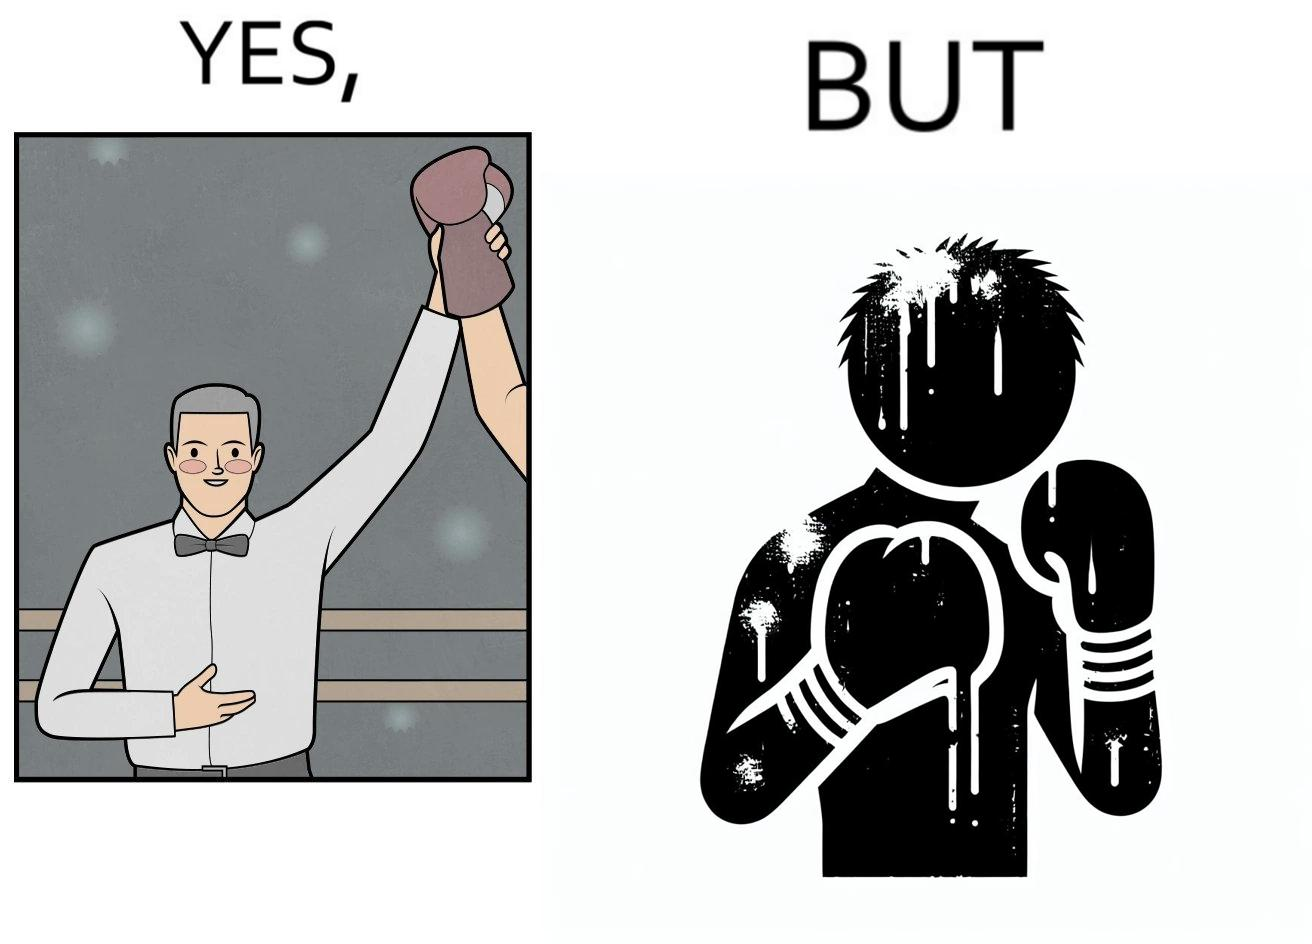What does this image depict? The image is ironic because even though a boxer has won the match and it is supposed to be a moment of celebration, the boxer got bruised in several places during the match. This is an illustration of what hurdles a person has to go through in order to succeed. 